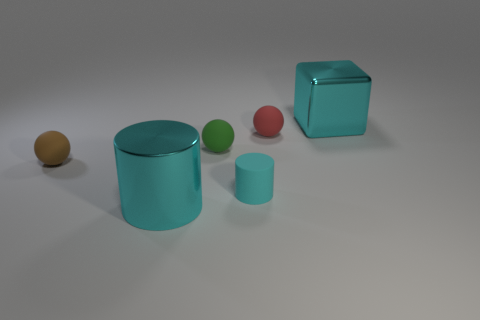Add 1 red cubes. How many objects exist? 7 Subtract all cubes. How many objects are left? 5 Subtract 1 cyan blocks. How many objects are left? 5 Subtract all cylinders. Subtract all brown cylinders. How many objects are left? 4 Add 3 small green balls. How many small green balls are left? 4 Add 3 spheres. How many spheres exist? 6 